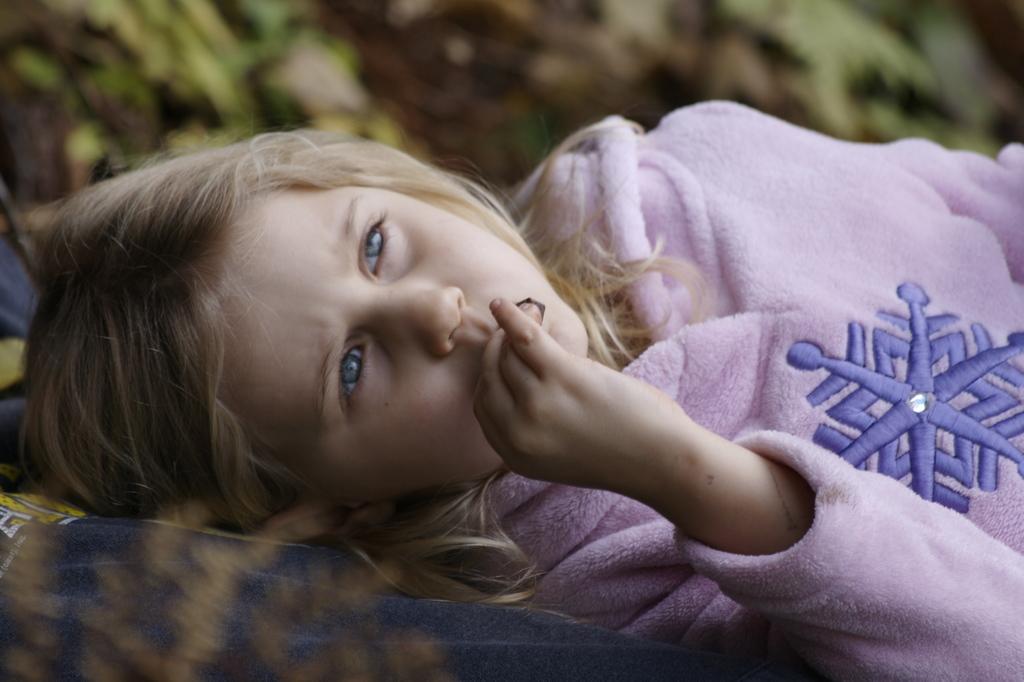In one or two sentences, can you explain what this image depicts? In this image we can see a child lying down. 